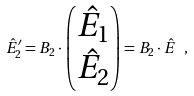Convert formula to latex. <formula><loc_0><loc_0><loc_500><loc_500>\hat { E } _ { 2 } ^ { \prime } = B _ { 2 } \cdot \begin{pmatrix} \hat { E } _ { 1 } \\ \hat { E } _ { 2 } \end{pmatrix} = B _ { 2 } \cdot \hat { E } \ ,</formula> 